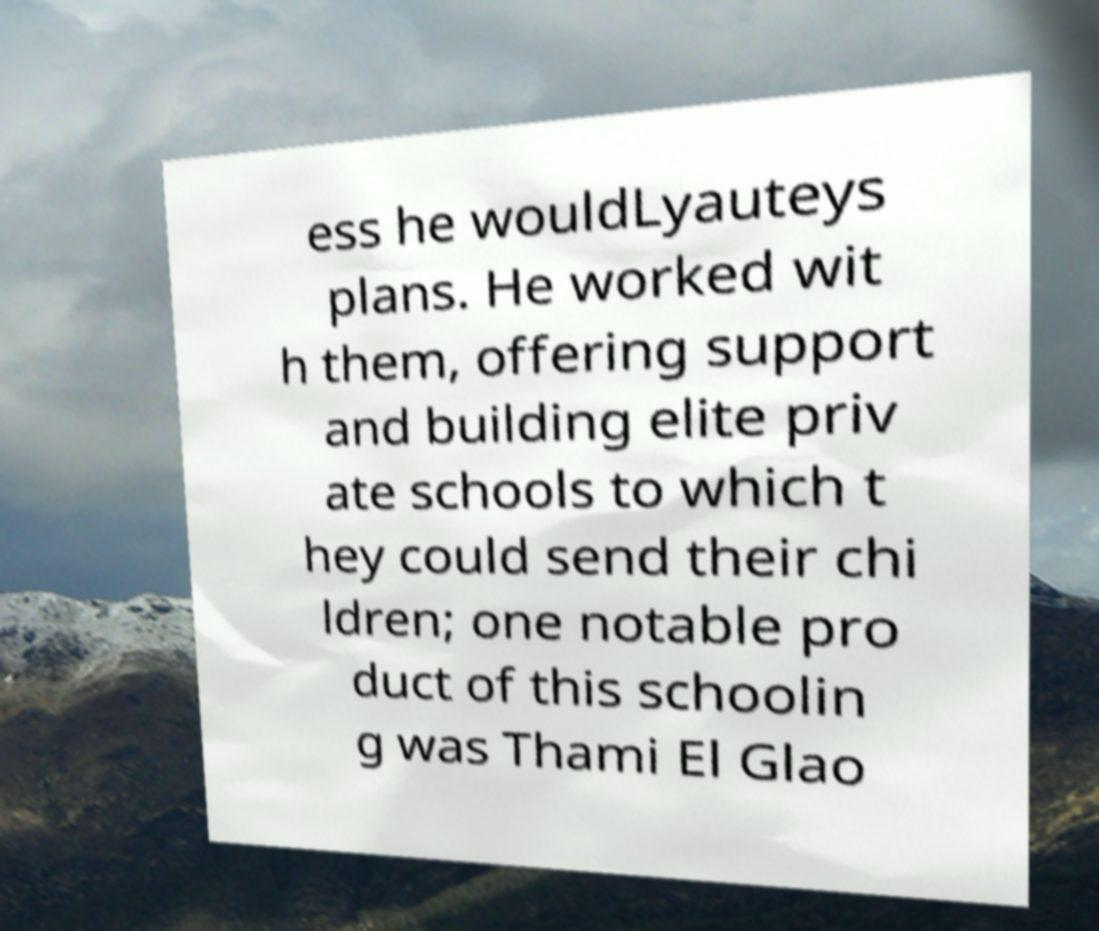I need the written content from this picture converted into text. Can you do that? ess he wouldLyauteys plans. He worked wit h them, offering support and building elite priv ate schools to which t hey could send their chi ldren; one notable pro duct of this schoolin g was Thami El Glao 